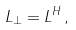<formula> <loc_0><loc_0><loc_500><loc_500>L _ { \perp } = L ^ { H } \, ,</formula> 